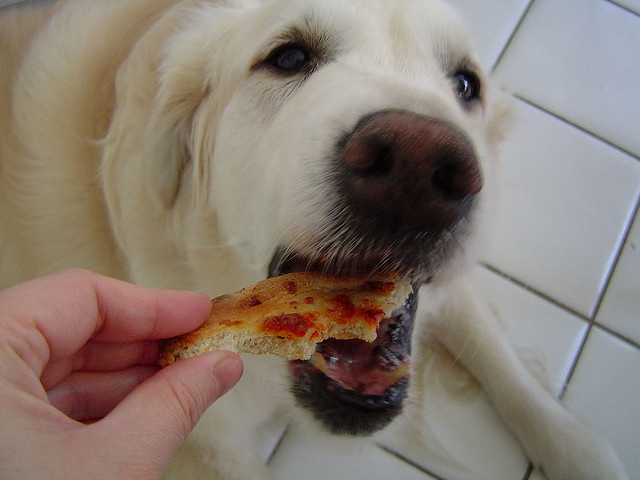Describe the objects in this image and their specific colors. I can see dog in gray, darkgray, and black tones, people in gray, maroon, and salmon tones, and pizza in gray, maroon, and brown tones in this image. 